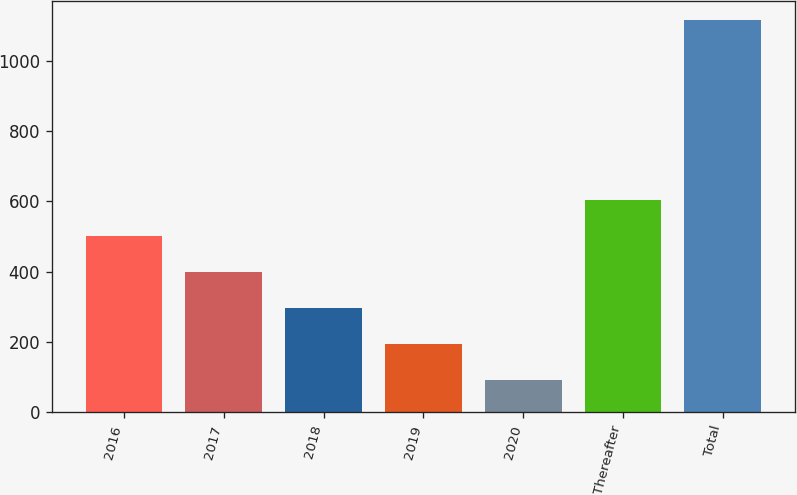Convert chart. <chart><loc_0><loc_0><loc_500><loc_500><bar_chart><fcel>2016<fcel>2017<fcel>2018<fcel>2019<fcel>2020<fcel>Thereafter<fcel>Total<nl><fcel>501.2<fcel>398.9<fcel>296.6<fcel>194.3<fcel>92<fcel>603.5<fcel>1115<nl></chart> 